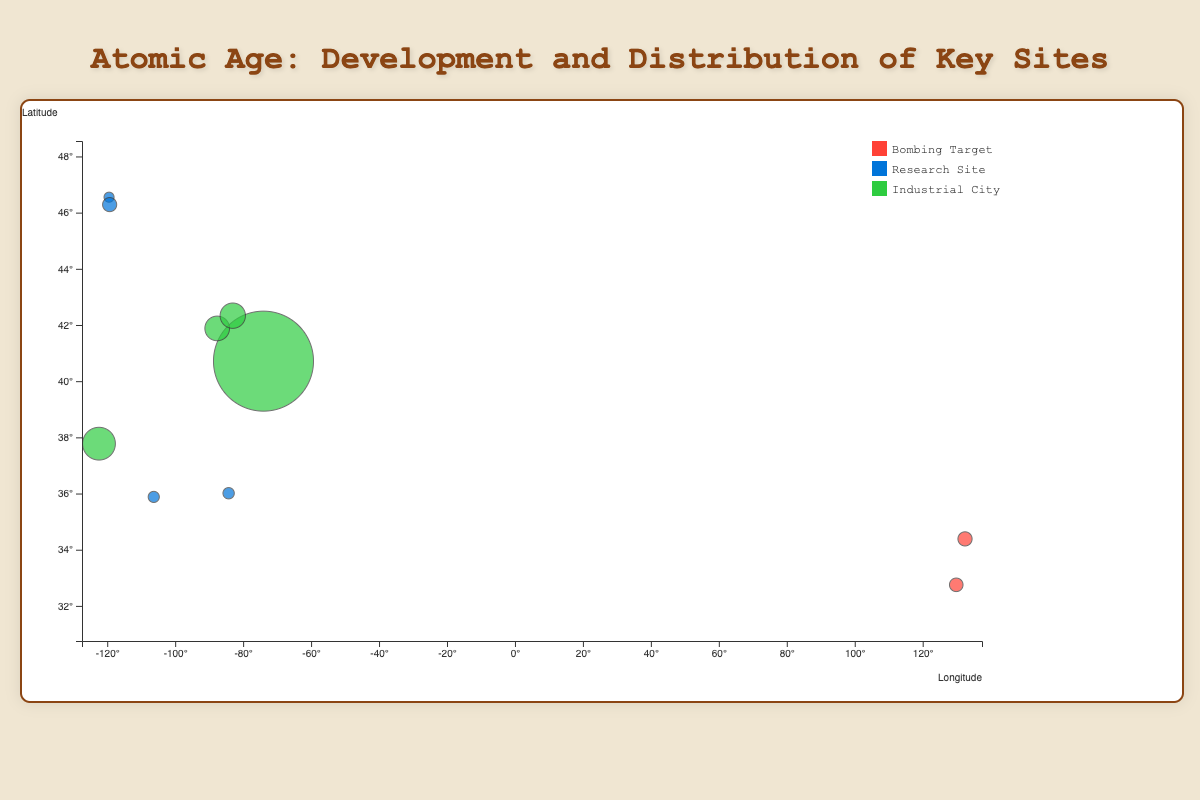What's the title of the figure? The title is prominently displayed at the top of the page.
Answer: Atomic Age: Development and Distribution of Key Sites Which color represents the research sites? The color legend on the right side of the figure indicates that research sites are represented by blue circles.
Answer: Blue How many bombing targets are represented on the chart? The tooltip indicates that Hiroshima and Nagasaki are bombing targets. By counting the circles colored as bombing targets (red), we find two of them.
Answer: 2 Which site has the highest population density? By comparing the sizes of the bubbles, it's evident that the bubble for New York City is the largest, indicating the highest population density.
Answer: New York City What are the longitude and latitude ranges shown on the x and y axes, respectively? The x-axis (longitude) ranges from about -125° to 140°, while the y-axis (latitude) ranges from about 30° to 50°.
Answer: Longitude: -125° to 140°, Latitude: 30° to 50° What is the population density of Chicago? By inspecting the tooltip when hovering over the Chicago bubble, it shows that the population density of Chicago is 4600/km².
Answer: 4600/km² Which site has the earliest year of establishment? The tooltip indicates that both Hiroshima (1589) and Nagasaki (1571) are the oldest. By comparing them, Nagasaki is the earliest.
Answer: Nagasaki Of the cities listed, which were established after 1900? By checking the tooltip for the year of establishment, we find that Oak Ridge (1942), Los Alamos (1943), and Richland (1906) were established after 1900.
Answer: Oak Ridge, Los Alamos, Richland Does New York City fall into the bombing target, research site, or industrial city category? Based on the color of the New York City circle and the legend, it falls under the industrial city category (green).
Answer: Industrial City Between Hanford and Oak Ridge, which has a higher population density? The bubbles for the two sites are compared: Hanford has no population density (0) while Oak Ridge has a population density of 401/km².
Answer: Oak Ridge 